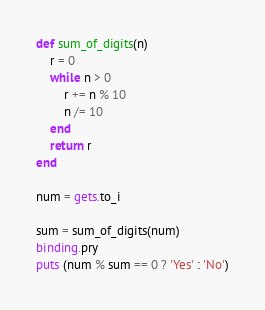Convert code to text. <code><loc_0><loc_0><loc_500><loc_500><_Ruby_>def sum_of_digits(n)
    r = 0
    while n > 0
        r += n % 10
        n /= 10
    end
    return r
end

num = gets.to_i

sum = sum_of_digits(num)
binding.pry
puts (num % sum == 0 ? 'Yes' : 'No')</code> 